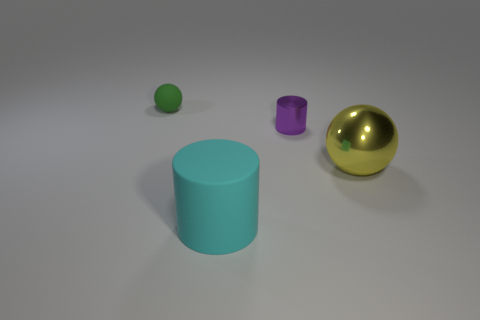Add 2 purple metallic things. How many objects exist? 6 Subtract all small cyan metallic balls. Subtract all yellow objects. How many objects are left? 3 Add 1 tiny purple objects. How many tiny purple objects are left? 2 Add 2 big yellow objects. How many big yellow objects exist? 3 Subtract 0 purple balls. How many objects are left? 4 